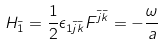Convert formula to latex. <formula><loc_0><loc_0><loc_500><loc_500>H _ { \bar { 1 } } = \frac { 1 } { 2 } \epsilon _ { 1 \bar { j } \bar { k } } F ^ { \bar { j } \bar { k } } = - \frac { \omega } { a }</formula> 